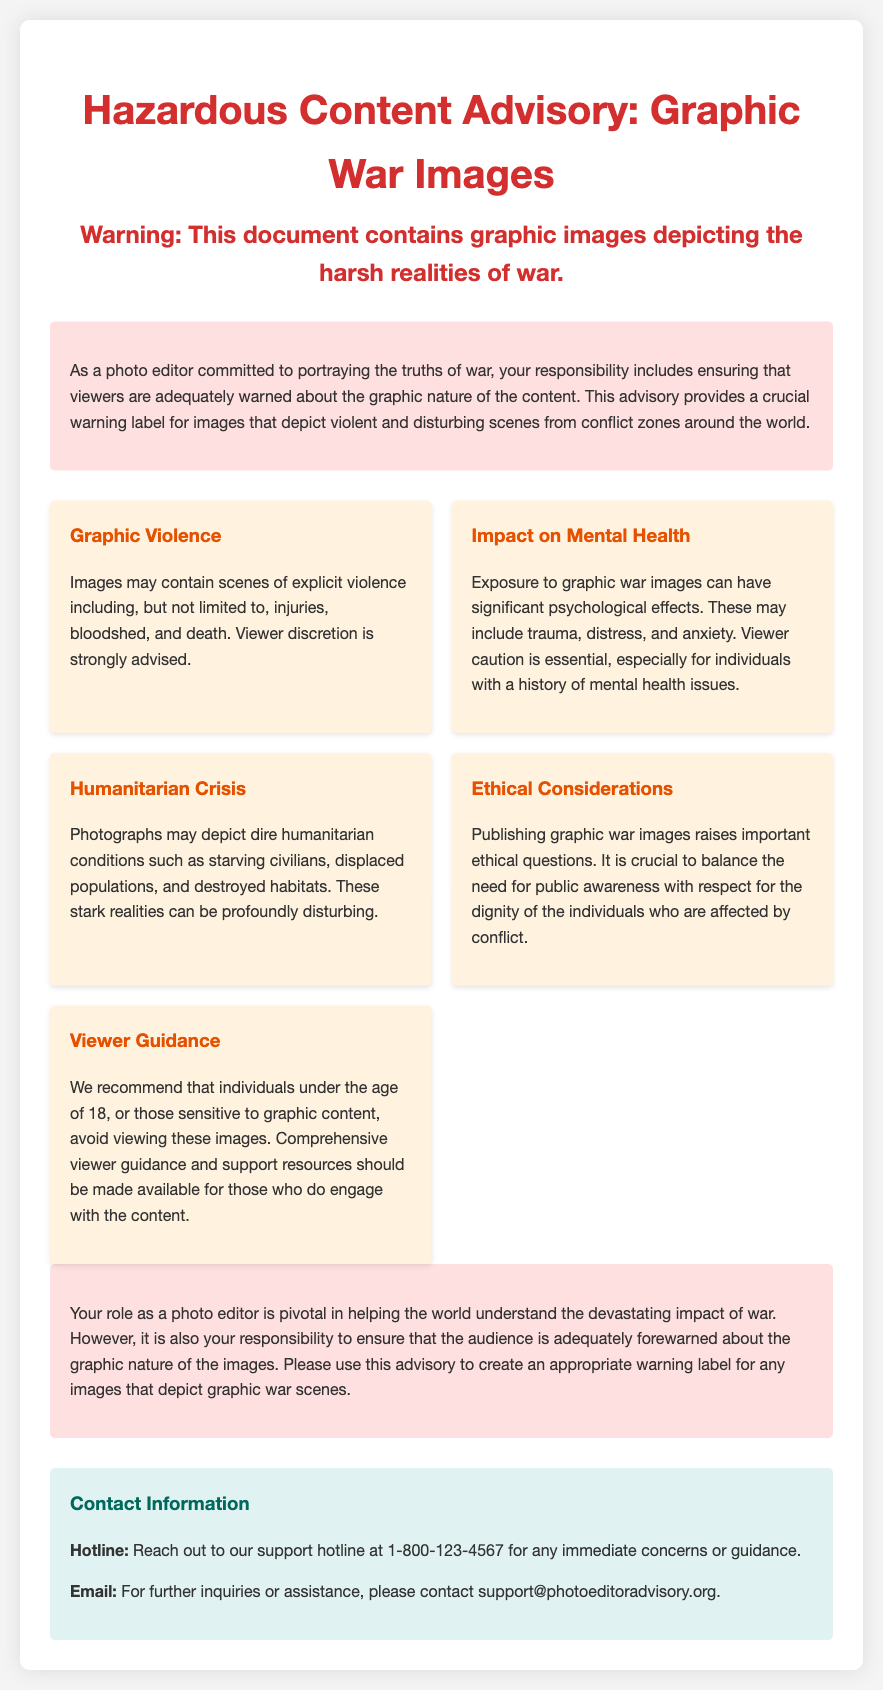What is the title of the advisory? The title of the advisory is explicitly stated at the top of the document.
Answer: Hazardous Content Advisory: Graphic War Images How many key points are listed in the document? The document lists specific aspects related to graphic war images under distinct categories.
Answer: Five What is recommended for individuals under the age of 18? The document provides specific viewer guidance related to age and sensitivity to graphic content.
Answer: Avoid viewing these images What psychological effects may result from viewing graphic war images? The advisory mentions several mental health issues associated with viewing such content.
Answer: Trauma What color is used for the headers? The document highlights the color scheme used for the headings in the advisory.
Answer: Red What type of ethical questions does the advisory raise? The content addresses the importance of maintaining ethical standards in publishing sensitive images.
Answer: Important ethical questions What should individuals do if they have immediate concerns? The document provides contact information for individuals seeking immediate help or guidance.
Answer: Reach out to the support hotline What is the hotline number provided? The advisory includes contact information for support, including a specific hotline number.
Answer: 1-800-123-4567 